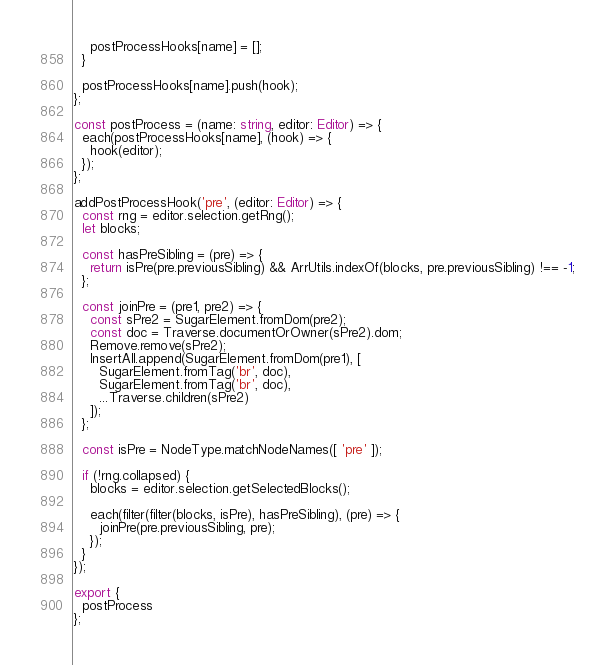Convert code to text. <code><loc_0><loc_0><loc_500><loc_500><_TypeScript_>    postProcessHooks[name] = [];
  }

  postProcessHooks[name].push(hook);
};

const postProcess = (name: string, editor: Editor) => {
  each(postProcessHooks[name], (hook) => {
    hook(editor);
  });
};

addPostProcessHook('pre', (editor: Editor) => {
  const rng = editor.selection.getRng();
  let blocks;

  const hasPreSibling = (pre) => {
    return isPre(pre.previousSibling) && ArrUtils.indexOf(blocks, pre.previousSibling) !== -1;
  };

  const joinPre = (pre1, pre2) => {
    const sPre2 = SugarElement.fromDom(pre2);
    const doc = Traverse.documentOrOwner(sPre2).dom;
    Remove.remove(sPre2);
    InsertAll.append(SugarElement.fromDom(pre1), [
      SugarElement.fromTag('br', doc),
      SugarElement.fromTag('br', doc),
      ...Traverse.children(sPre2)
    ]);
  };

  const isPre = NodeType.matchNodeNames([ 'pre' ]);

  if (!rng.collapsed) {
    blocks = editor.selection.getSelectedBlocks();

    each(filter(filter(blocks, isPre), hasPreSibling), (pre) => {
      joinPre(pre.previousSibling, pre);
    });
  }
});

export {
  postProcess
};
</code> 